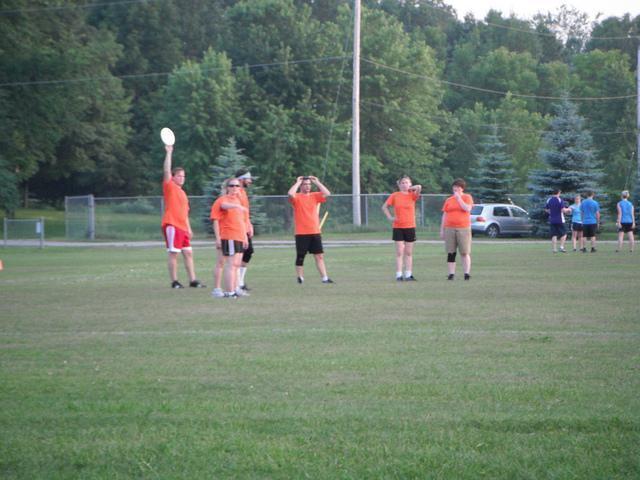How many teams are there?
Give a very brief answer. 2. How many people are in the photo?
Give a very brief answer. 5. How many black cats are there in the image ?
Give a very brief answer. 0. 